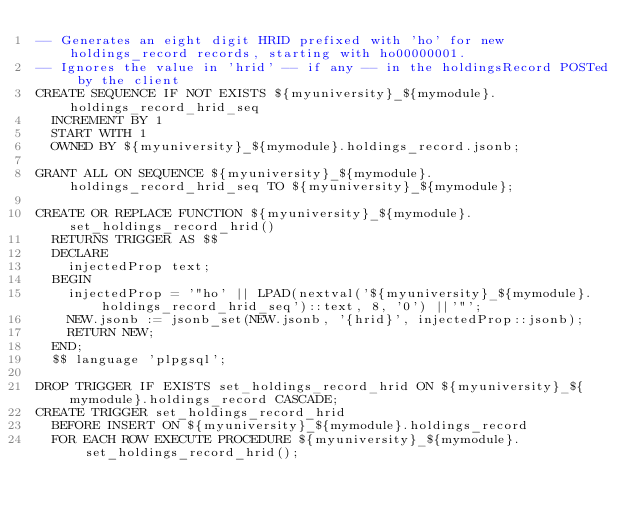<code> <loc_0><loc_0><loc_500><loc_500><_SQL_>-- Generates an eight digit HRID prefixed with 'ho' for new holdings_record records, starting with ho00000001.
-- Ignores the value in 'hrid' -- if any -- in the holdingsRecord POSTed by the client 
CREATE SEQUENCE IF NOT EXISTS ${myuniversity}_${mymodule}.holdings_record_hrid_seq
  INCREMENT BY 1
  START WITH 1
  OWNED BY ${myuniversity}_${mymodule}.holdings_record.jsonb;

GRANT ALL ON SEQUENCE ${myuniversity}_${mymodule}.holdings_record_hrid_seq TO ${myuniversity}_${mymodule};

CREATE OR REPLACE FUNCTION ${myuniversity}_${mymodule}.set_holdings_record_hrid()
  RETURNS TRIGGER AS $$
  DECLARE
    injectedProp text;
  BEGIN
    injectedProp = '"ho' || LPAD(nextval('${myuniversity}_${mymodule}.holdings_record_hrid_seq')::text, 8, '0') ||'"';
    NEW.jsonb := jsonb_set(NEW.jsonb, '{hrid}', injectedProp::jsonb);
    RETURN NEW;
  END;
  $$ language 'plpgsql';

DROP TRIGGER IF EXISTS set_holdings_record_hrid ON ${myuniversity}_${mymodule}.holdings_record CASCADE;
CREATE TRIGGER set_holdings_record_hrid
  BEFORE INSERT ON ${myuniversity}_${mymodule}.holdings_record
  FOR EACH ROW EXECUTE PROCEDURE ${myuniversity}_${mymodule}.set_holdings_record_hrid();


</code> 